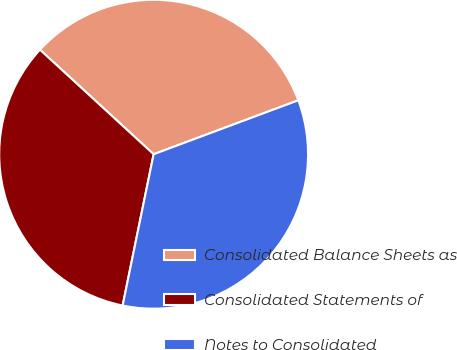Convert chart. <chart><loc_0><loc_0><loc_500><loc_500><pie_chart><fcel>Consolidated Balance Sheets as<fcel>Consolidated Statements of<fcel>Notes to Consolidated<nl><fcel>32.49%<fcel>33.62%<fcel>33.9%<nl></chart> 